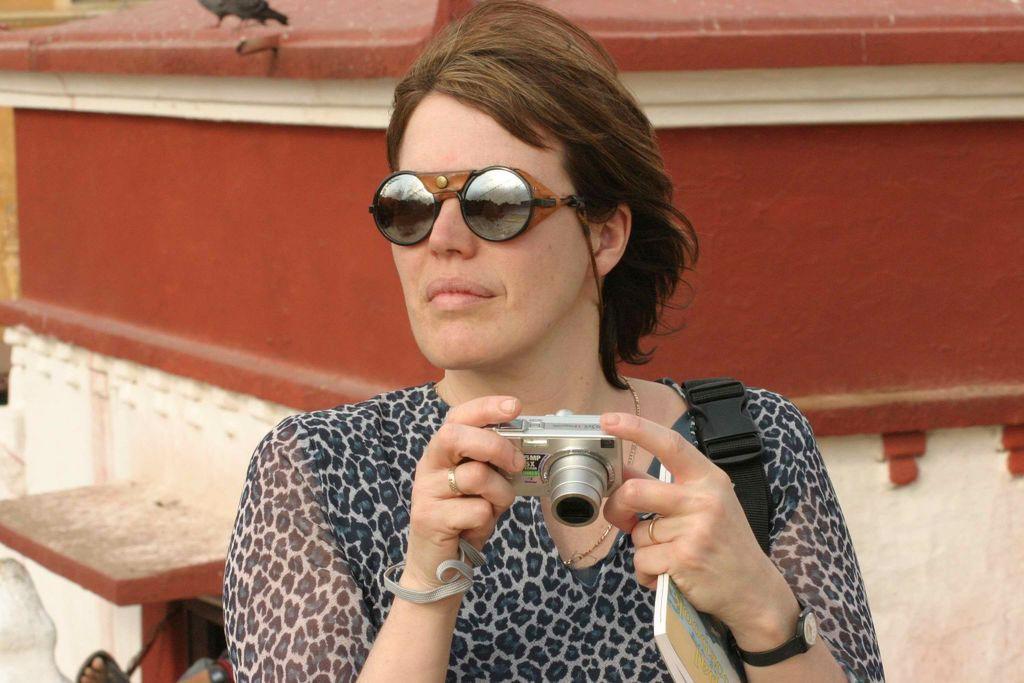Describe this image in one or two sentences. This picture shows a woman seated and holding a camera in her hand and we see sunglasses on her face and she holds a book in her hand 